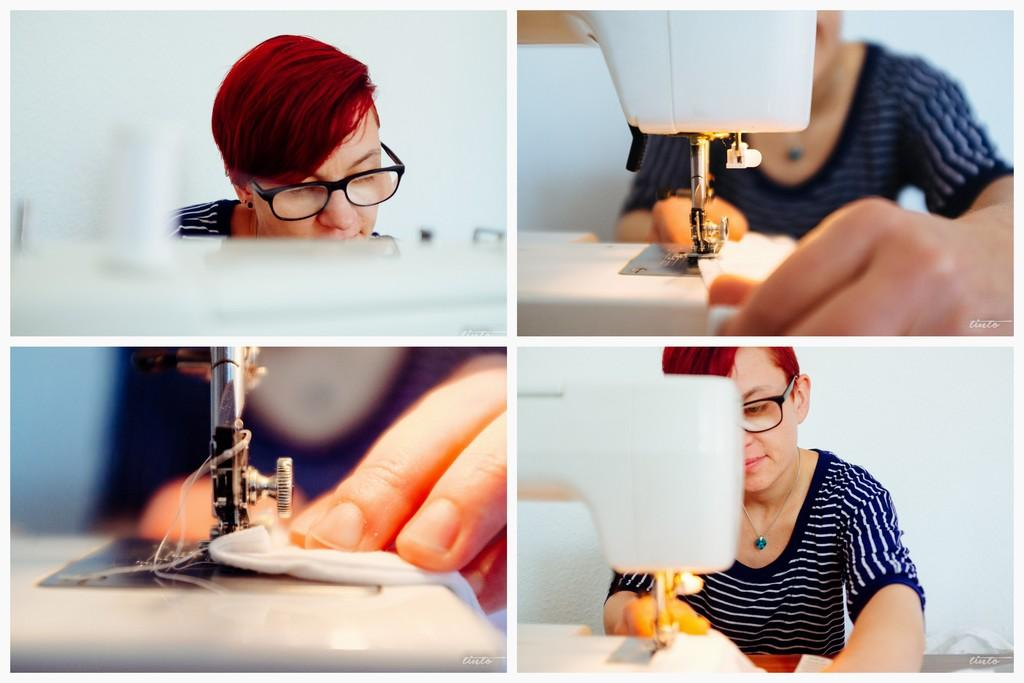Who is present in the image? There is a person in the image. What is the person wearing? The person is wearing a blue dress. What object can be seen in the image related to sewing or crafting? There is a sewing machine in the image. What type of knot is being tied by the person in the image? There is no knot-tying activity depicted in the image; the person is simply wearing a blue dress. 